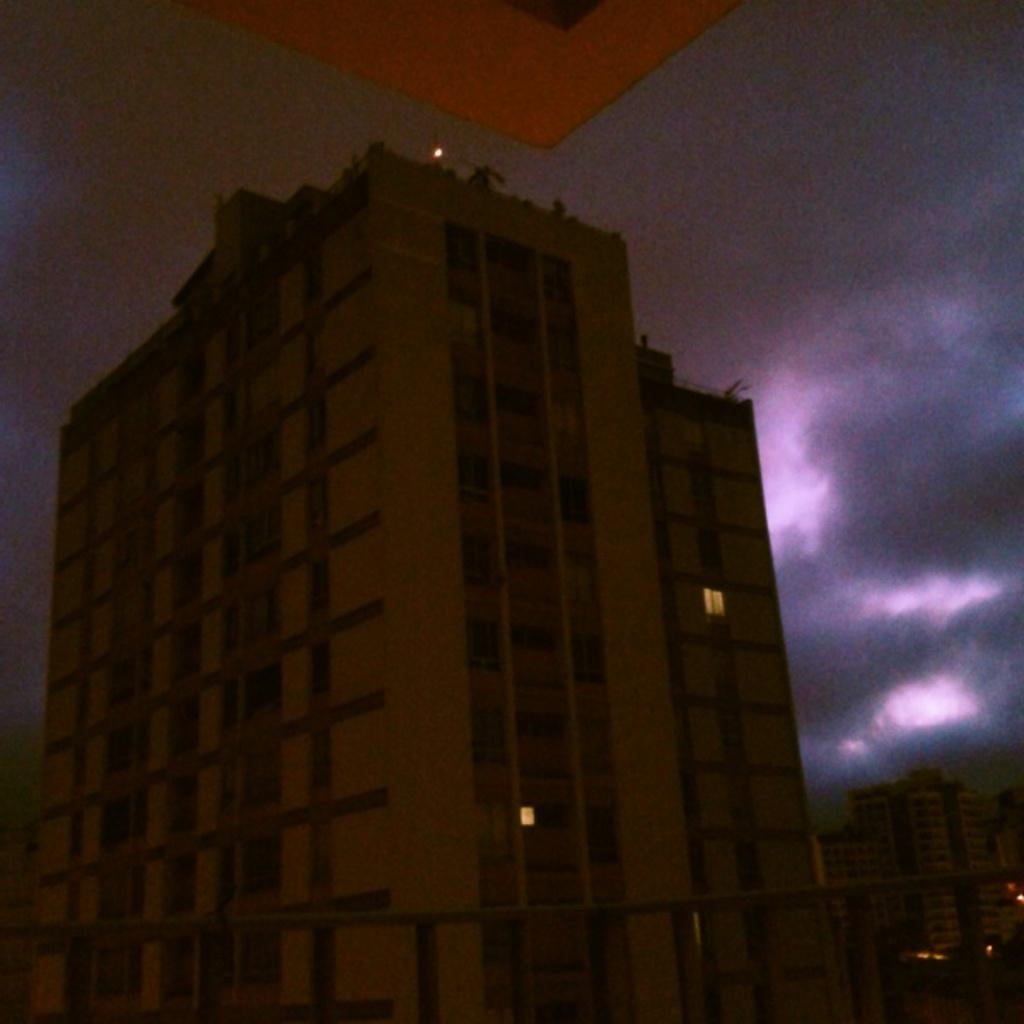What type of structure is present in the image? There is a building in the image. What can be seen in the background of the image? The sky is visible in the background of the image. Can you describe the sky's position in relation to the building? The sky is also visible in front of the building. What type of holiday is being celebrated in the image? There is no indication of a holiday being celebrated in the image. Can you see the ocean in the image? The image does not show the ocean; it only features a building and the sky. 